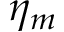Convert formula to latex. <formula><loc_0><loc_0><loc_500><loc_500>\eta _ { m }</formula> 